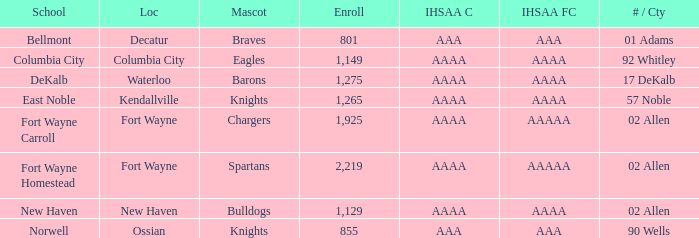What's the IHSAA Football Class in Decatur with an AAA IHSAA class? AAA. 